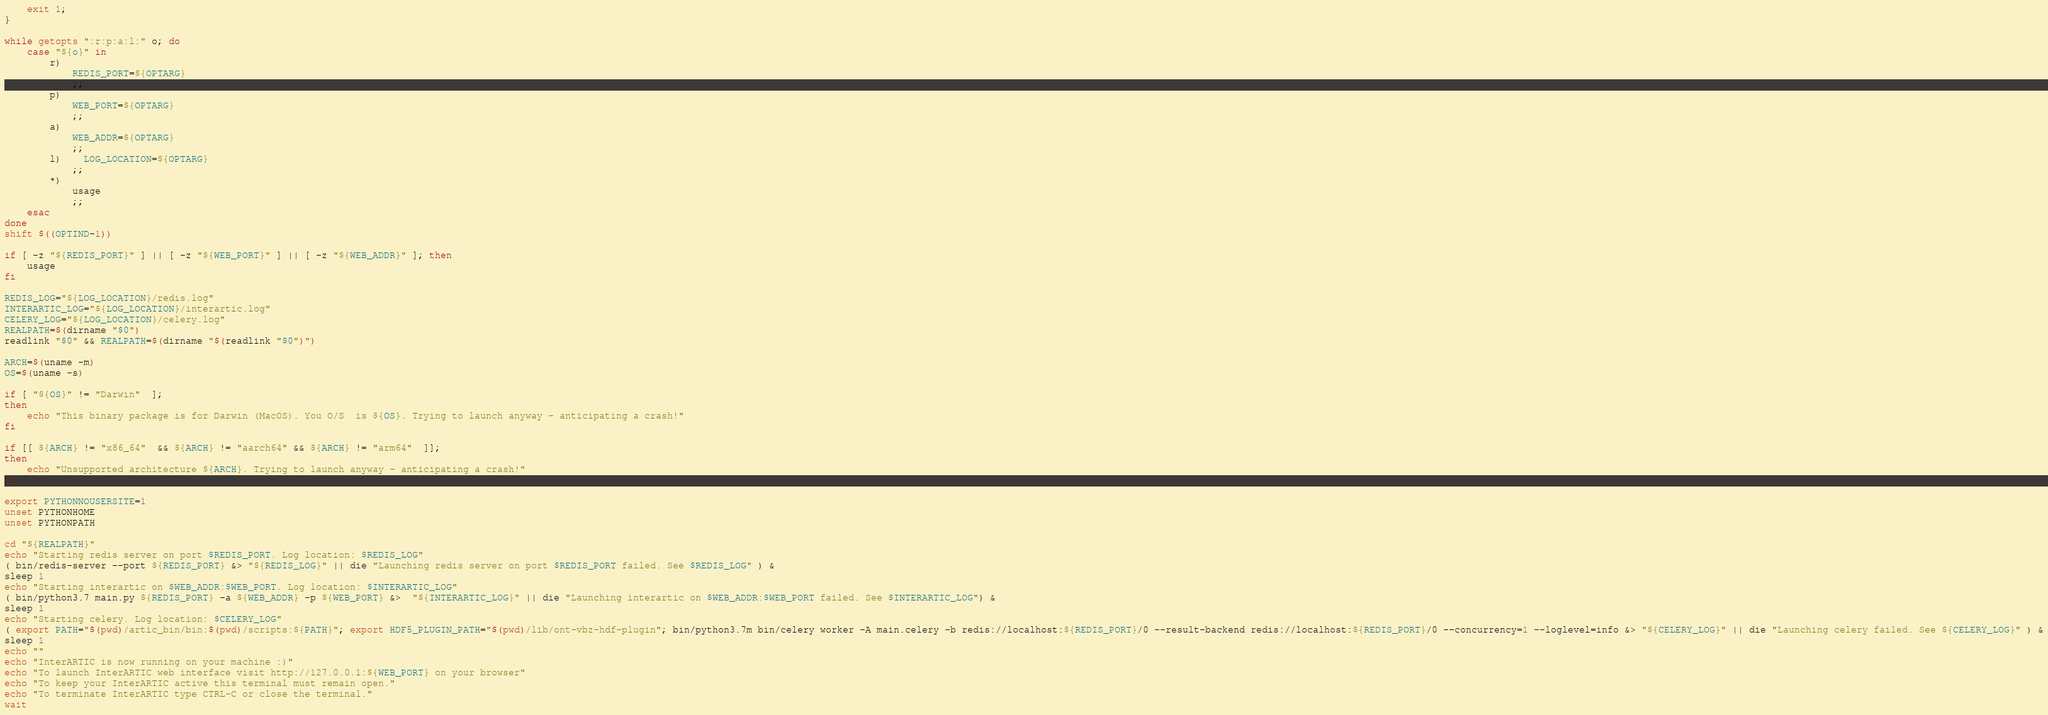Convert code to text. <code><loc_0><loc_0><loc_500><loc_500><_Bash_>	exit 1;
}

while getopts ":r:p:a:l:" o; do
    case "${o}" in
        r)
            REDIS_PORT=${OPTARG}
            ;;
        p)
            WEB_PORT=${OPTARG}
            ;;
        a)
            WEB_ADDR=${OPTARG}
            ;;
		l)	LOG_LOCATION=${OPTARG}
			;;
        *)
            usage
            ;;
    esac
done
shift $((OPTIND-1))

if [ -z "${REDIS_PORT}" ] || [ -z "${WEB_PORT}" ] || [ -z "${WEB_ADDR}" ]; then
    usage
fi

REDIS_LOG="${LOG_LOCATION}/redis.log"
INTERARTIC_LOG="${LOG_LOCATION}/interartic.log"
CELERY_LOG="${LOG_LOCATION}/celery.log"
REALPATH=$(dirname "$0")
readlink "$0" && REALPATH=$(dirname "$(readlink "$0")")

ARCH=$(uname -m)
OS=$(uname -s)

if [ "${OS}" != "Darwin"  ];
then
    echo "This binary package is for Darwin (MacOS). You O/S  is ${OS}. Trying to launch anyway - anticipating a crash!"
fi

if [[ ${ARCH} != "x86_64"  && ${ARCH} != "aarch64" && ${ARCH} != "arm64"  ]];
then
    echo "Unsupported architecture ${ARCH}. Trying to launch anyway - anticipating a crash!"
fi

export PYTHONNOUSERSITE=1
unset PYTHONHOME
unset PYTHONPATH

cd "${REALPATH}"
echo "Starting redis server on port $REDIS_PORT. Log location: $REDIS_LOG"
( bin/redis-server --port ${REDIS_PORT} &> "${REDIS_LOG}" || die "Launching redis server on port $REDIS_PORT failed. See $REDIS_LOG" ) &
sleep 1
echo "Starting interartic on $WEB_ADDR:$WEB_PORT. Log location: $INTERARTIC_LOG"
( bin/python3.7 main.py ${REDIS_PORT} -a ${WEB_ADDR} -p ${WEB_PORT} &>  "${INTERARTIC_LOG}" || die "Launching interartic on $WEB_ADDR:$WEB_PORT failed. See $INTERARTIC_LOG") &
sleep 1
echo "Starting celery. Log location: $CELERY_LOG"
( export PATH="$(pwd)/artic_bin/bin:$(pwd)/scripts:${PATH}"; export HDF5_PLUGIN_PATH="$(pwd)/lib/ont-vbz-hdf-plugin"; bin/python3.7m bin/celery worker -A main.celery -b redis://localhost:${REDIS_PORT}/0 --result-backend redis://localhost:${REDIS_PORT}/0 --concurrency=1 --loglevel=info &> "${CELERY_LOG}" || die "Launching celery failed. See ${CELERY_LOG}" ) &
sleep 1
echo ""
echo "InterARTIC is now running on your machine :)"
echo "To launch InterARTIC web interface visit http://127.0.0.1:${WEB_PORT} on your browser"
echo "To keep your InterARTIC active this terminal must remain open."
echo "To terminate InterARTIC type CTRL-C or close the terminal."
wait
</code> 